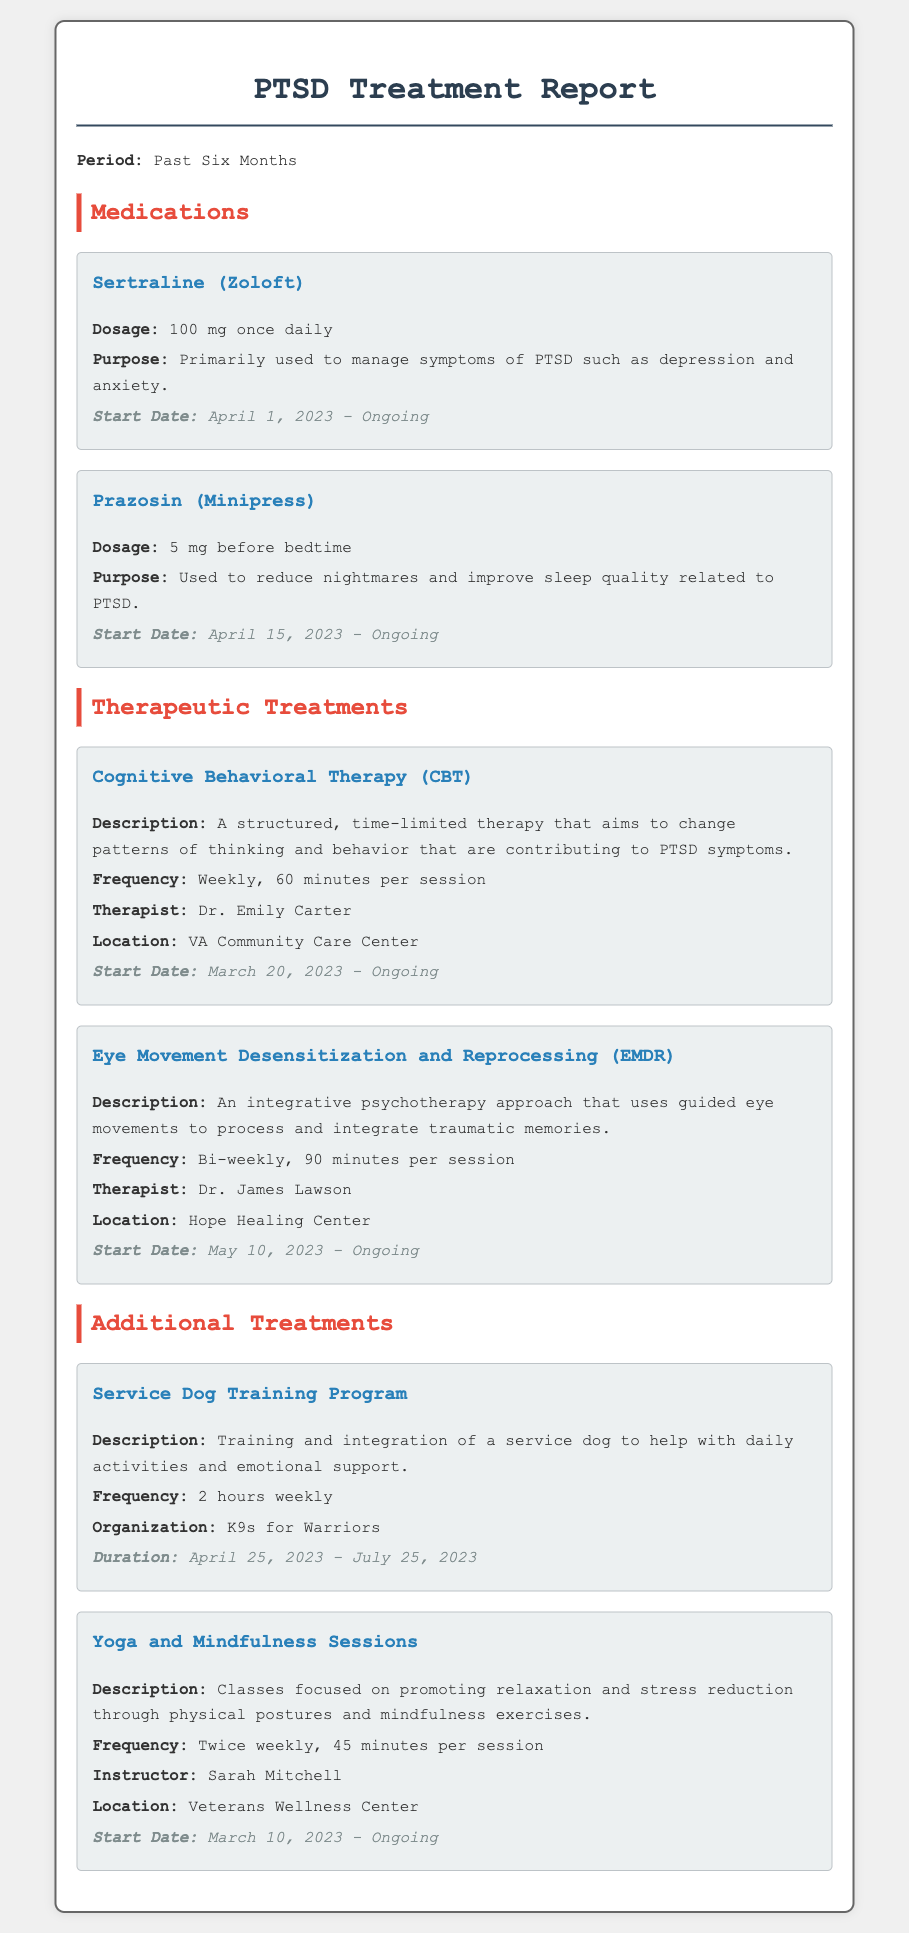what medication is prescribed for depression and anxiety? The medication prescribed for depression and anxiety is Sertraline (Zoloft).
Answer: Sertraline (Zoloft) when did the service dog training program start? The service dog training program started on April 25, 2023.
Answer: April 25, 2023 how often are the Yoga and Mindfulness Sessions held? The Yoga and Mindfulness Sessions are held twice weekly.
Answer: Twice weekly who is the therapist for Cognitive Behavioral Therapy? The therapist for Cognitive Behavioral Therapy is Dr. Emily Carter.
Answer: Dr. Emily Carter what is the dosage of Prazosin? The dosage of Prazosin is 5 mg before bedtime.
Answer: 5 mg before bedtime how long is each session of Eye Movement Desensitization and Reprocessing (EMDR)? Each session of EMDR is 90 minutes long.
Answer: 90 minutes what is the purpose of Prazosin? The purpose of Prazosin is to reduce nightmares and improve sleep quality related to PTSD.
Answer: Reduce nightmares and improve sleep quality when did Cognitive Behavioral Therapy start? Cognitive Behavioral Therapy started on March 20, 2023.
Answer: March 20, 2023 which organization provides the service dog training? The organization that provides the service dog training is K9s for Warriors.
Answer: K9s for Warriors 